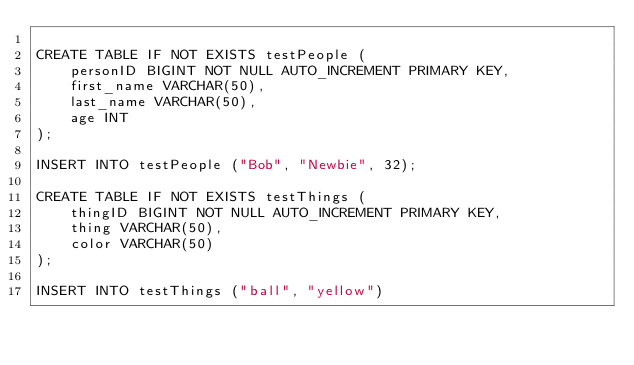<code> <loc_0><loc_0><loc_500><loc_500><_SQL_>
CREATE TABLE IF NOT EXISTS testPeople (
    personID BIGINT NOT NULL AUTO_INCREMENT PRIMARY KEY,
    first_name VARCHAR(50),
    last_name VARCHAR(50),
    age INT
);

INSERT INTO testPeople ("Bob", "Newbie", 32);

CREATE TABLE IF NOT EXISTS testThings (
    thingID BIGINT NOT NULL AUTO_INCREMENT PRIMARY KEY,
    thing VARCHAR(50),
    color VARCHAR(50)
);

INSERT INTO testThings ("ball", "yellow")</code> 